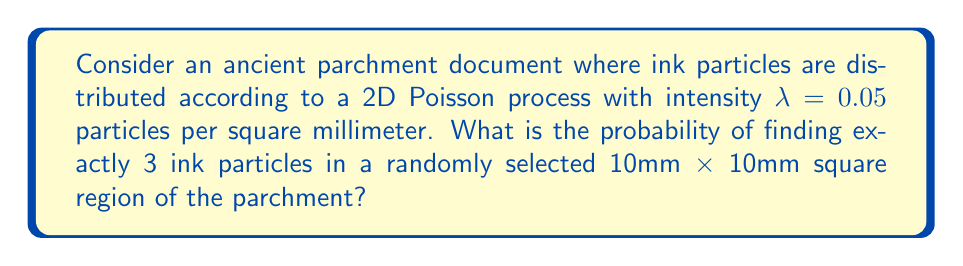Can you answer this question? To solve this problem, we'll follow these steps:

1) First, we need to understand that a 2D Poisson process models events (in this case, ink particles) that occur randomly and independently in a two-dimensional space.

2) The probability of finding exactly $k$ events in an area $A$ for a 2D Poisson process with intensity $\lambda$ is given by the Poisson probability mass function:

   $$P(X = k) = \frac{(\lambda A)^k e^{-\lambda A}}{k!}$$

3) In our case:
   - $k = 3$ (we're looking for exactly 3 particles)
   - $\lambda = 0.05$ particles per square millimeter
   - $A = 10 \text{ mm} \times 10 \text{ mm} = 100 \text{ mm}^2$

4) Let's calculate $\lambda A$:
   $$\lambda A = 0.05 \times 100 = 5$$

5) Now we can plug these values into our formula:

   $$P(X = 3) = \frac{5^3 e^{-5}}{3!}$$

6) Let's calculate this step by step:
   - $5^3 = 125$
   - $e^{-5} \approx 0.00673795$
   - $3! = 6$

   $$P(X = 3) = \frac{125 \times 0.00673795}{6} \approx 0.14037$$

7) Therefore, the probability of finding exactly 3 ink particles in a randomly selected 10mm x 10mm square region is approximately 0.14037 or about 14.04%.
Answer: 0.14037 